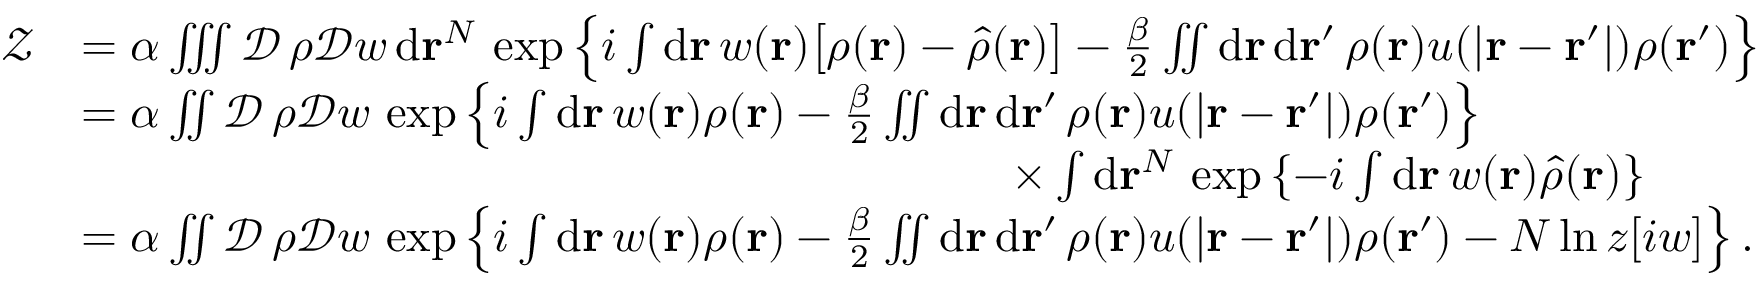<formula> <loc_0><loc_0><loc_500><loc_500>\begin{array} { r l } { \mathcal { Z } } & { = \alpha \iiint \mathcal { D } \, \rho \mathcal { D } w \, d r ^ { N } \, \exp \left \{ i \int d r \, w ( r ) \left [ \rho ( r ) - \hat { \rho } ( r ) \right ] - \frac { \beta } { 2 } \iint d r \, d r ^ { \prime } \, \rho ( r ) u ( | r - r ^ { \prime } | ) \rho ( r ^ { \prime } ) \right \} } \\ & { = \alpha \iint \mathcal { D } \, \rho \mathcal { D } w \, \exp \left \{ i \int d r \, w ( r ) \rho ( r ) - \frac { \beta } { 2 } \iint d r \, d r ^ { \prime } \, \rho ( r ) u ( | r - r ^ { \prime } | ) \rho ( r ^ { \prime } ) \right \} } \\ & { \quad \times \int d r ^ { N } \, \exp \left \{ - i \int d r \, w ( r ) \hat { \rho } ( r ) \right \} } \\ & { = \alpha \iint \mathcal { D } \, \rho \mathcal { D } w \, \exp \left \{ i \int d r \, w ( r ) \rho ( r ) - \frac { \beta } { 2 } \iint d r \, d r ^ { \prime } \, \rho ( r ) u ( | r - r ^ { \prime } | ) \rho ( r ^ { \prime } ) - N \ln z [ i w ] \right \} . } \end{array}</formula> 